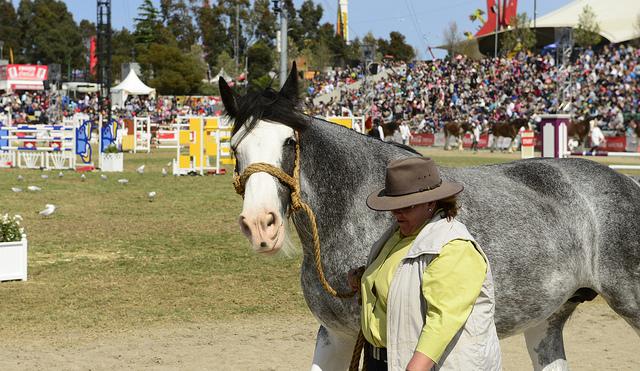Is this horse participating in a rodeo?
Concise answer only. Yes. What color is the horse's nose?
Answer briefly. Pink. Is the woman with the horse wearing a hat?
Short answer required. Yes. 